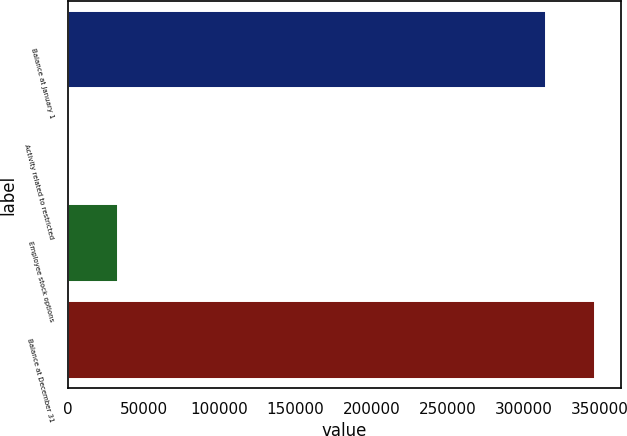<chart> <loc_0><loc_0><loc_500><loc_500><bar_chart><fcel>Balance at January 1<fcel>Activity related to restricted<fcel>Employee stock options<fcel>Balance at December 31<nl><fcel>315018<fcel>941<fcel>32906.9<fcel>346984<nl></chart> 